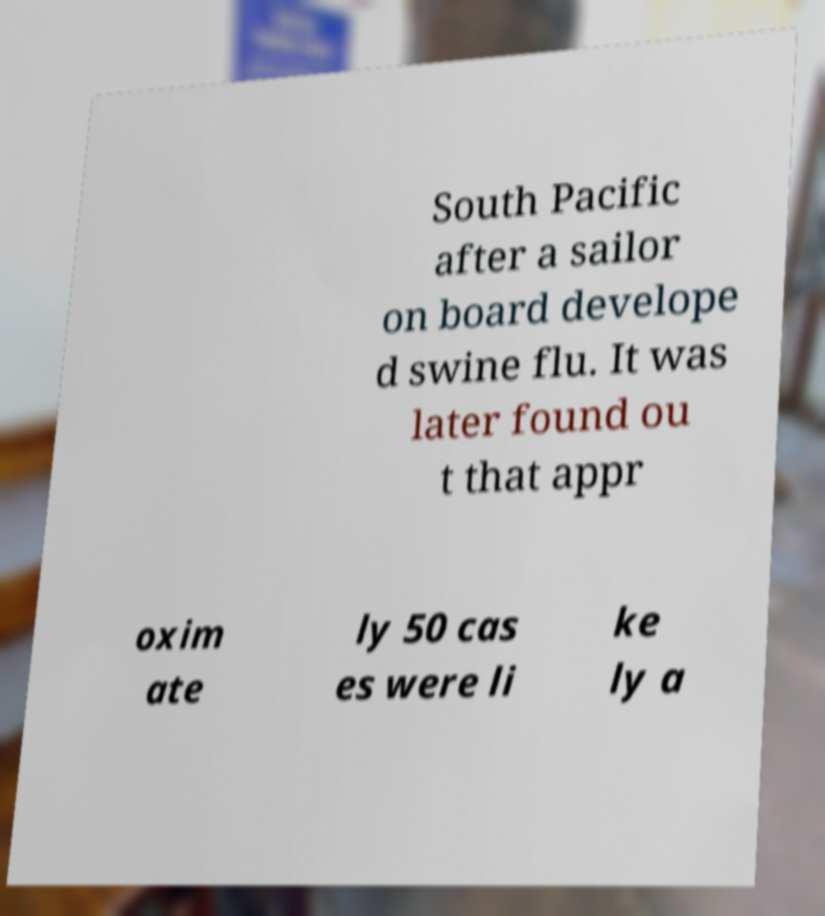Can you read and provide the text displayed in the image?This photo seems to have some interesting text. Can you extract and type it out for me? South Pacific after a sailor on board develope d swine flu. It was later found ou t that appr oxim ate ly 50 cas es were li ke ly a 